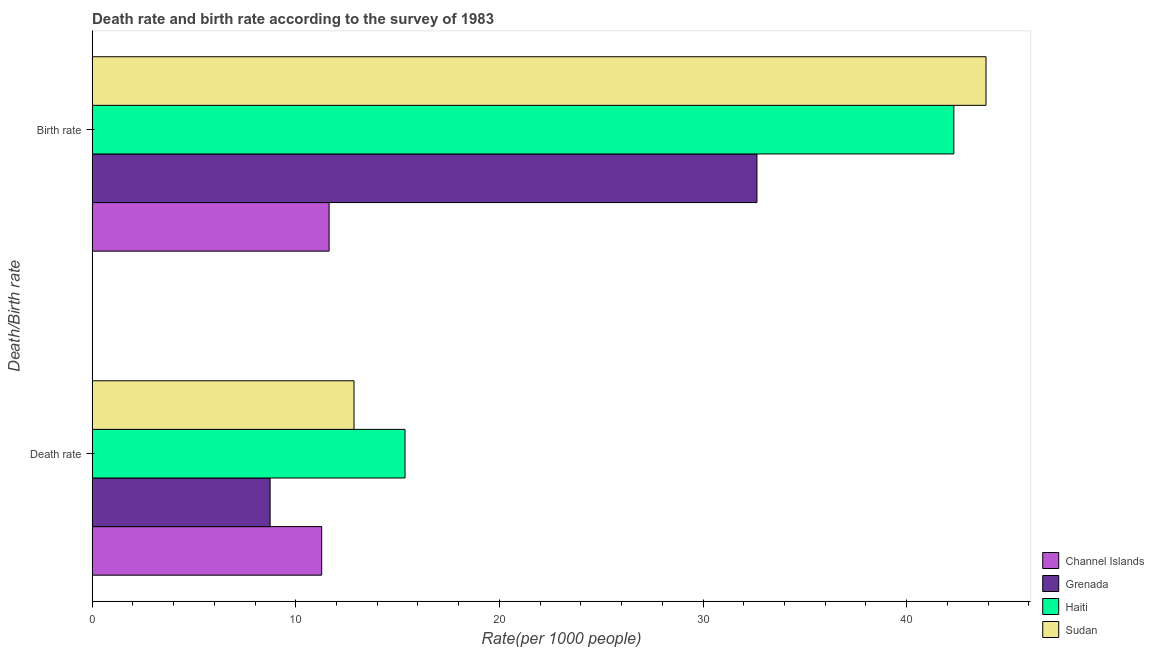How many different coloured bars are there?
Provide a succinct answer. 4. How many groups of bars are there?
Make the answer very short. 2. How many bars are there on the 1st tick from the top?
Your answer should be compact. 4. How many bars are there on the 2nd tick from the bottom?
Make the answer very short. 4. What is the label of the 2nd group of bars from the top?
Ensure brevity in your answer.  Death rate. What is the birth rate in Channel Islands?
Provide a succinct answer. 11.64. Across all countries, what is the maximum death rate?
Your answer should be compact. 15.37. Across all countries, what is the minimum death rate?
Your answer should be very brief. 8.74. In which country was the birth rate maximum?
Your answer should be compact. Sudan. In which country was the birth rate minimum?
Offer a terse response. Channel Islands. What is the total birth rate in the graph?
Offer a very short reply. 130.5. What is the difference between the death rate in Channel Islands and that in Sudan?
Make the answer very short. -1.59. What is the difference between the death rate in Channel Islands and the birth rate in Haiti?
Keep it short and to the point. -31.04. What is the average death rate per country?
Ensure brevity in your answer.  12.06. What is the difference between the birth rate and death rate in Grenada?
Your answer should be compact. 23.91. What is the ratio of the death rate in Sudan to that in Grenada?
Make the answer very short. 1.47. Is the birth rate in Channel Islands less than that in Haiti?
Give a very brief answer. Yes. What does the 1st bar from the top in Death rate represents?
Give a very brief answer. Sudan. What does the 3rd bar from the bottom in Birth rate represents?
Make the answer very short. Haiti. How many bars are there?
Keep it short and to the point. 8. How many countries are there in the graph?
Keep it short and to the point. 4. Does the graph contain any zero values?
Offer a terse response. No. Does the graph contain grids?
Offer a very short reply. No. Where does the legend appear in the graph?
Make the answer very short. Bottom right. How many legend labels are there?
Offer a terse response. 4. How are the legend labels stacked?
Your response must be concise. Vertical. What is the title of the graph?
Offer a very short reply. Death rate and birth rate according to the survey of 1983. What is the label or title of the X-axis?
Your answer should be compact. Rate(per 1000 people). What is the label or title of the Y-axis?
Offer a very short reply. Death/Birth rate. What is the Rate(per 1000 people) of Channel Islands in Death rate?
Provide a succinct answer. 11.28. What is the Rate(per 1000 people) of Grenada in Death rate?
Provide a short and direct response. 8.74. What is the Rate(per 1000 people) of Haiti in Death rate?
Offer a very short reply. 15.37. What is the Rate(per 1000 people) in Sudan in Death rate?
Your answer should be compact. 12.86. What is the Rate(per 1000 people) in Channel Islands in Birth rate?
Your answer should be very brief. 11.64. What is the Rate(per 1000 people) in Grenada in Birth rate?
Your answer should be compact. 32.65. What is the Rate(per 1000 people) of Haiti in Birth rate?
Keep it short and to the point. 42.32. What is the Rate(per 1000 people) in Sudan in Birth rate?
Ensure brevity in your answer.  43.9. Across all Death/Birth rate, what is the maximum Rate(per 1000 people) in Channel Islands?
Your answer should be very brief. 11.64. Across all Death/Birth rate, what is the maximum Rate(per 1000 people) of Grenada?
Your answer should be very brief. 32.65. Across all Death/Birth rate, what is the maximum Rate(per 1000 people) in Haiti?
Offer a terse response. 42.32. Across all Death/Birth rate, what is the maximum Rate(per 1000 people) in Sudan?
Make the answer very short. 43.9. Across all Death/Birth rate, what is the minimum Rate(per 1000 people) of Channel Islands?
Offer a terse response. 11.28. Across all Death/Birth rate, what is the minimum Rate(per 1000 people) of Grenada?
Offer a terse response. 8.74. Across all Death/Birth rate, what is the minimum Rate(per 1000 people) in Haiti?
Provide a short and direct response. 15.37. Across all Death/Birth rate, what is the minimum Rate(per 1000 people) of Sudan?
Offer a very short reply. 12.86. What is the total Rate(per 1000 people) in Channel Islands in the graph?
Your response must be concise. 22.91. What is the total Rate(per 1000 people) in Grenada in the graph?
Keep it short and to the point. 41.39. What is the total Rate(per 1000 people) in Haiti in the graph?
Keep it short and to the point. 57.69. What is the total Rate(per 1000 people) of Sudan in the graph?
Give a very brief answer. 56.76. What is the difference between the Rate(per 1000 people) in Channel Islands in Death rate and that in Birth rate?
Provide a short and direct response. -0.36. What is the difference between the Rate(per 1000 people) in Grenada in Death rate and that in Birth rate?
Your answer should be very brief. -23.91. What is the difference between the Rate(per 1000 people) of Haiti in Death rate and that in Birth rate?
Provide a succinct answer. -26.95. What is the difference between the Rate(per 1000 people) of Sudan in Death rate and that in Birth rate?
Give a very brief answer. -31.04. What is the difference between the Rate(per 1000 people) in Channel Islands in Death rate and the Rate(per 1000 people) in Grenada in Birth rate?
Give a very brief answer. -21.37. What is the difference between the Rate(per 1000 people) of Channel Islands in Death rate and the Rate(per 1000 people) of Haiti in Birth rate?
Your response must be concise. -31.04. What is the difference between the Rate(per 1000 people) of Channel Islands in Death rate and the Rate(per 1000 people) of Sudan in Birth rate?
Give a very brief answer. -32.62. What is the difference between the Rate(per 1000 people) in Grenada in Death rate and the Rate(per 1000 people) in Haiti in Birth rate?
Provide a short and direct response. -33.58. What is the difference between the Rate(per 1000 people) in Grenada in Death rate and the Rate(per 1000 people) in Sudan in Birth rate?
Give a very brief answer. -35.16. What is the difference between the Rate(per 1000 people) in Haiti in Death rate and the Rate(per 1000 people) in Sudan in Birth rate?
Your response must be concise. -28.53. What is the average Rate(per 1000 people) in Channel Islands per Death/Birth rate?
Make the answer very short. 11.46. What is the average Rate(per 1000 people) of Grenada per Death/Birth rate?
Your answer should be compact. 20.7. What is the average Rate(per 1000 people) of Haiti per Death/Birth rate?
Offer a terse response. 28.84. What is the average Rate(per 1000 people) in Sudan per Death/Birth rate?
Your answer should be compact. 28.38. What is the difference between the Rate(per 1000 people) of Channel Islands and Rate(per 1000 people) of Grenada in Death rate?
Your answer should be very brief. 2.53. What is the difference between the Rate(per 1000 people) of Channel Islands and Rate(per 1000 people) of Haiti in Death rate?
Provide a succinct answer. -4.09. What is the difference between the Rate(per 1000 people) of Channel Islands and Rate(per 1000 people) of Sudan in Death rate?
Give a very brief answer. -1.59. What is the difference between the Rate(per 1000 people) in Grenada and Rate(per 1000 people) in Haiti in Death rate?
Provide a short and direct response. -6.62. What is the difference between the Rate(per 1000 people) of Grenada and Rate(per 1000 people) of Sudan in Death rate?
Keep it short and to the point. -4.12. What is the difference between the Rate(per 1000 people) of Haiti and Rate(per 1000 people) of Sudan in Death rate?
Provide a short and direct response. 2.5. What is the difference between the Rate(per 1000 people) in Channel Islands and Rate(per 1000 people) in Grenada in Birth rate?
Give a very brief answer. -21.01. What is the difference between the Rate(per 1000 people) of Channel Islands and Rate(per 1000 people) of Haiti in Birth rate?
Provide a short and direct response. -30.68. What is the difference between the Rate(per 1000 people) in Channel Islands and Rate(per 1000 people) in Sudan in Birth rate?
Provide a succinct answer. -32.26. What is the difference between the Rate(per 1000 people) in Grenada and Rate(per 1000 people) in Haiti in Birth rate?
Give a very brief answer. -9.67. What is the difference between the Rate(per 1000 people) of Grenada and Rate(per 1000 people) of Sudan in Birth rate?
Your answer should be compact. -11.25. What is the difference between the Rate(per 1000 people) of Haiti and Rate(per 1000 people) of Sudan in Birth rate?
Your answer should be compact. -1.58. What is the ratio of the Rate(per 1000 people) of Channel Islands in Death rate to that in Birth rate?
Keep it short and to the point. 0.97. What is the ratio of the Rate(per 1000 people) in Grenada in Death rate to that in Birth rate?
Ensure brevity in your answer.  0.27. What is the ratio of the Rate(per 1000 people) in Haiti in Death rate to that in Birth rate?
Your answer should be compact. 0.36. What is the ratio of the Rate(per 1000 people) in Sudan in Death rate to that in Birth rate?
Keep it short and to the point. 0.29. What is the difference between the highest and the second highest Rate(per 1000 people) of Channel Islands?
Give a very brief answer. 0.36. What is the difference between the highest and the second highest Rate(per 1000 people) in Grenada?
Provide a succinct answer. 23.91. What is the difference between the highest and the second highest Rate(per 1000 people) in Haiti?
Ensure brevity in your answer.  26.95. What is the difference between the highest and the second highest Rate(per 1000 people) in Sudan?
Offer a terse response. 31.04. What is the difference between the highest and the lowest Rate(per 1000 people) in Channel Islands?
Provide a short and direct response. 0.36. What is the difference between the highest and the lowest Rate(per 1000 people) of Grenada?
Offer a terse response. 23.91. What is the difference between the highest and the lowest Rate(per 1000 people) of Haiti?
Make the answer very short. 26.95. What is the difference between the highest and the lowest Rate(per 1000 people) in Sudan?
Provide a succinct answer. 31.04. 